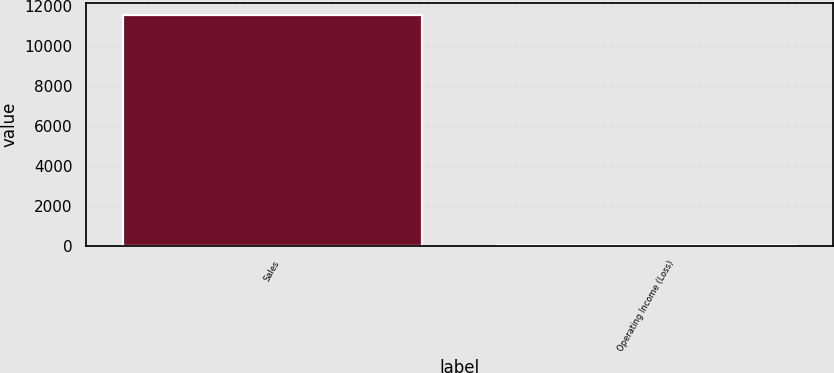Convert chart to OTSL. <chart><loc_0><loc_0><loc_500><loc_500><bar_chart><fcel>Sales<fcel>Operating Income (Loss)<nl><fcel>11540<fcel>51<nl></chart> 